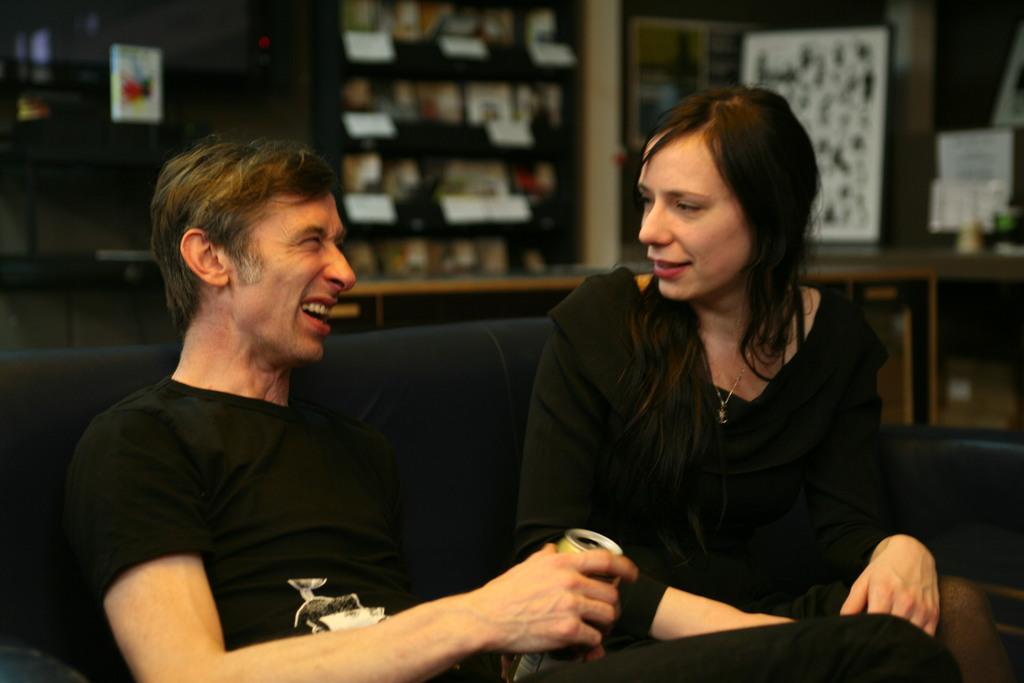Can you describe this image briefly? In the foreground of the picture there are couple sitting in a couch, they are wearing black dress. The background is blurred. In the background there are desk, closet, books, posters, board and many objects. 